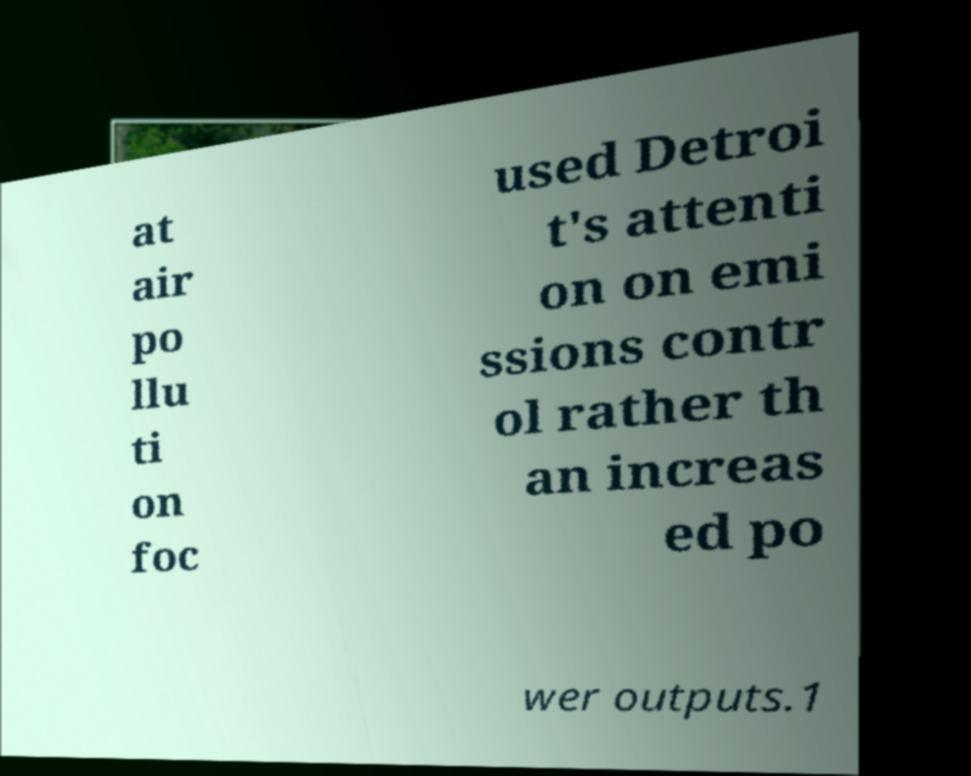Could you assist in decoding the text presented in this image and type it out clearly? at air po llu ti on foc used Detroi t's attenti on on emi ssions contr ol rather th an increas ed po wer outputs.1 